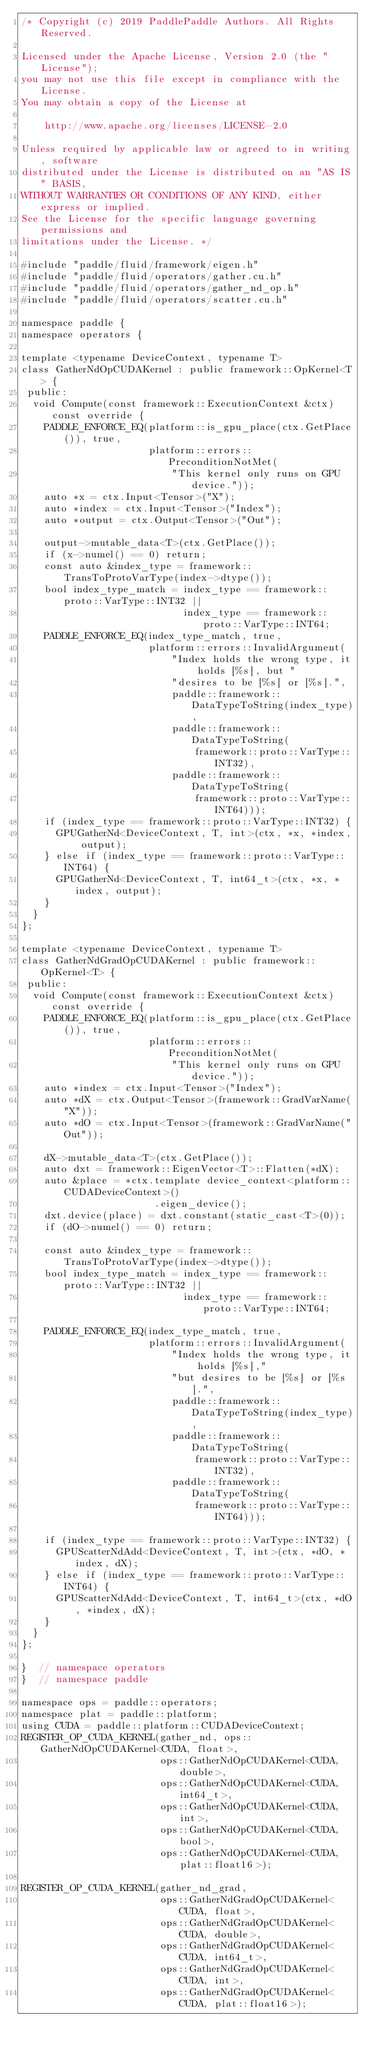<code> <loc_0><loc_0><loc_500><loc_500><_Cuda_>/* Copyright (c) 2019 PaddlePaddle Authors. All Rights Reserved.

Licensed under the Apache License, Version 2.0 (the "License");
you may not use this file except in compliance with the License.
You may obtain a copy of the License at

    http://www.apache.org/licenses/LICENSE-2.0

Unless required by applicable law or agreed to in writing, software
distributed under the License is distributed on an "AS IS" BASIS,
WITHOUT WARRANTIES OR CONDITIONS OF ANY KIND, either express or implied.
See the License for the specific language governing permissions and
limitations under the License. */

#include "paddle/fluid/framework/eigen.h"
#include "paddle/fluid/operators/gather.cu.h"
#include "paddle/fluid/operators/gather_nd_op.h"
#include "paddle/fluid/operators/scatter.cu.h"

namespace paddle {
namespace operators {

template <typename DeviceContext, typename T>
class GatherNdOpCUDAKernel : public framework::OpKernel<T> {
 public:
  void Compute(const framework::ExecutionContext &ctx) const override {
    PADDLE_ENFORCE_EQ(platform::is_gpu_place(ctx.GetPlace()), true,
                      platform::errors::PreconditionNotMet(
                          "This kernel only runs on GPU device."));
    auto *x = ctx.Input<Tensor>("X");
    auto *index = ctx.Input<Tensor>("Index");
    auto *output = ctx.Output<Tensor>("Out");

    output->mutable_data<T>(ctx.GetPlace());
    if (x->numel() == 0) return;
    const auto &index_type = framework::TransToProtoVarType(index->dtype());
    bool index_type_match = index_type == framework::proto::VarType::INT32 ||
                            index_type == framework::proto::VarType::INT64;
    PADDLE_ENFORCE_EQ(index_type_match, true,
                      platform::errors::InvalidArgument(
                          "Index holds the wrong type, it holds [%s], but "
                          "desires to be [%s] or [%s].",
                          paddle::framework::DataTypeToString(index_type),
                          paddle::framework::DataTypeToString(
                              framework::proto::VarType::INT32),
                          paddle::framework::DataTypeToString(
                              framework::proto::VarType::INT64)));
    if (index_type == framework::proto::VarType::INT32) {
      GPUGatherNd<DeviceContext, T, int>(ctx, *x, *index, output);
    } else if (index_type == framework::proto::VarType::INT64) {
      GPUGatherNd<DeviceContext, T, int64_t>(ctx, *x, *index, output);
    }
  }
};

template <typename DeviceContext, typename T>
class GatherNdGradOpCUDAKernel : public framework::OpKernel<T> {
 public:
  void Compute(const framework::ExecutionContext &ctx) const override {
    PADDLE_ENFORCE_EQ(platform::is_gpu_place(ctx.GetPlace()), true,
                      platform::errors::PreconditionNotMet(
                          "This kernel only runs on GPU device."));
    auto *index = ctx.Input<Tensor>("Index");
    auto *dX = ctx.Output<Tensor>(framework::GradVarName("X"));
    auto *dO = ctx.Input<Tensor>(framework::GradVarName("Out"));

    dX->mutable_data<T>(ctx.GetPlace());
    auto dxt = framework::EigenVector<T>::Flatten(*dX);
    auto &place = *ctx.template device_context<platform::CUDADeviceContext>()
                       .eigen_device();
    dxt.device(place) = dxt.constant(static_cast<T>(0));
    if (dO->numel() == 0) return;

    const auto &index_type = framework::TransToProtoVarType(index->dtype());
    bool index_type_match = index_type == framework::proto::VarType::INT32 ||
                            index_type == framework::proto::VarType::INT64;

    PADDLE_ENFORCE_EQ(index_type_match, true,
                      platform::errors::InvalidArgument(
                          "Index holds the wrong type, it holds [%s],"
                          "but desires to be [%s] or [%s].",
                          paddle::framework::DataTypeToString(index_type),
                          paddle::framework::DataTypeToString(
                              framework::proto::VarType::INT32),
                          paddle::framework::DataTypeToString(
                              framework::proto::VarType::INT64)));

    if (index_type == framework::proto::VarType::INT32) {
      GPUScatterNdAdd<DeviceContext, T, int>(ctx, *dO, *index, dX);
    } else if (index_type == framework::proto::VarType::INT64) {
      GPUScatterNdAdd<DeviceContext, T, int64_t>(ctx, *dO, *index, dX);
    }
  }
};

}  // namespace operators
}  // namespace paddle

namespace ops = paddle::operators;
namespace plat = paddle::platform;
using CUDA = paddle::platform::CUDADeviceContext;
REGISTER_OP_CUDA_KERNEL(gather_nd, ops::GatherNdOpCUDAKernel<CUDA, float>,
                        ops::GatherNdOpCUDAKernel<CUDA, double>,
                        ops::GatherNdOpCUDAKernel<CUDA, int64_t>,
                        ops::GatherNdOpCUDAKernel<CUDA, int>,
                        ops::GatherNdOpCUDAKernel<CUDA, bool>,
                        ops::GatherNdOpCUDAKernel<CUDA, plat::float16>);

REGISTER_OP_CUDA_KERNEL(gather_nd_grad,
                        ops::GatherNdGradOpCUDAKernel<CUDA, float>,
                        ops::GatherNdGradOpCUDAKernel<CUDA, double>,
                        ops::GatherNdGradOpCUDAKernel<CUDA, int64_t>,
                        ops::GatherNdGradOpCUDAKernel<CUDA, int>,
                        ops::GatherNdGradOpCUDAKernel<CUDA, plat::float16>);
</code> 